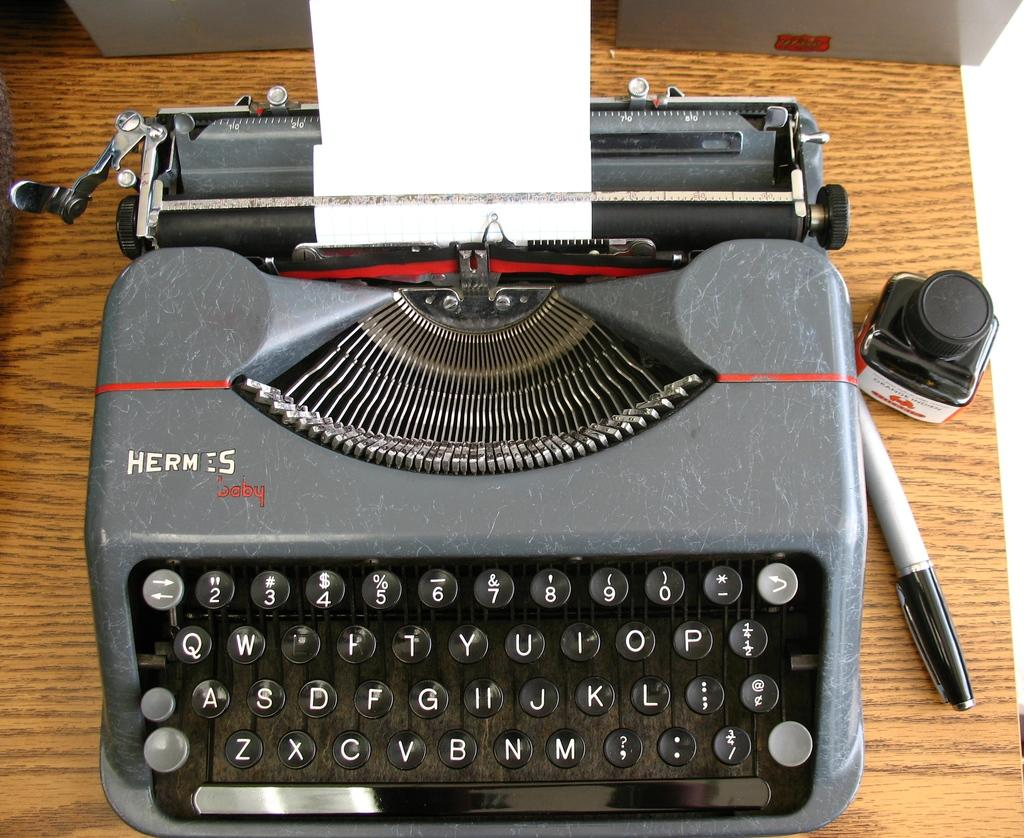<image>
Describe the image concisely. An old Hermes Baby typewriter sitting on a brown table. 